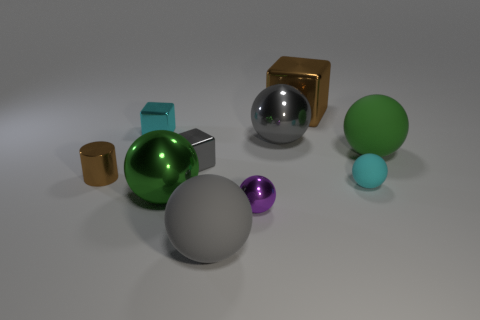Subtract all gray spheres. How many were subtracted if there are1gray spheres left? 1 Subtract 2 balls. How many balls are left? 4 Subtract all cyan spheres. How many spheres are left? 5 Subtract all gray metal spheres. How many spheres are left? 5 Subtract all green balls. Subtract all yellow cylinders. How many balls are left? 4 Subtract all cylinders. How many objects are left? 9 Add 8 small cylinders. How many small cylinders exist? 9 Subtract 0 green cylinders. How many objects are left? 10 Subtract all cyan cubes. Subtract all small matte balls. How many objects are left? 8 Add 8 brown metallic blocks. How many brown metallic blocks are left? 9 